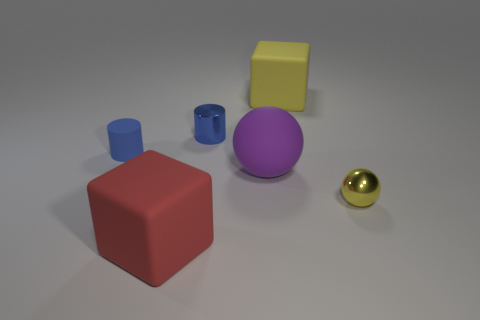There is a blue metal object; is it the same shape as the big rubber object in front of the small yellow sphere?
Offer a very short reply. No. How many other objects are the same material as the big yellow cube?
Your answer should be compact. 3. Do the big ball and the large thing behind the small rubber cylinder have the same color?
Make the answer very short. No. There is a large object that is to the left of the big sphere; what is its material?
Your response must be concise. Rubber. Is there a big shiny cylinder of the same color as the tiny metallic sphere?
Offer a terse response. No. There is a matte object that is the same size as the blue shiny thing; what is its color?
Your response must be concise. Blue. How many big things are yellow things or red matte cubes?
Make the answer very short. 2. Are there the same number of red rubber objects right of the yellow shiny sphere and small blue cylinders behind the tiny rubber object?
Give a very brief answer. No. What number of yellow objects have the same size as the yellow cube?
Offer a terse response. 0. How many cyan things are either tiny metallic balls or large matte objects?
Provide a short and direct response. 0. 